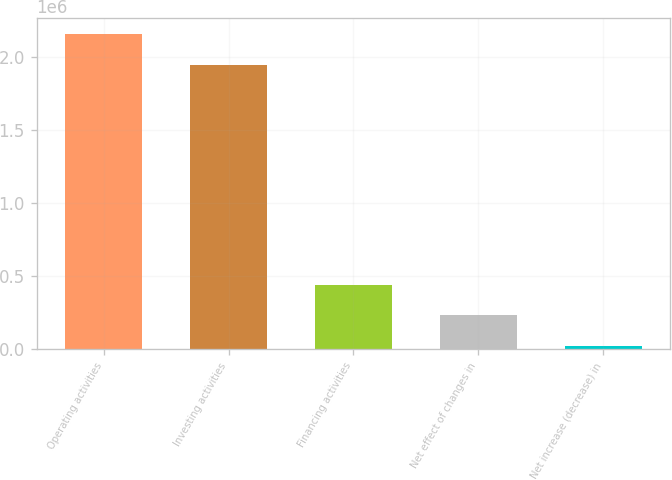Convert chart to OTSL. <chart><loc_0><loc_0><loc_500><loc_500><bar_chart><fcel>Operating activities<fcel>Investing activities<fcel>Financing activities<fcel>Net effect of changes in<fcel>Net increase (decrease) in<nl><fcel>2.16102e+06<fcel>1.94955e+06<fcel>442851<fcel>231383<fcel>19916<nl></chart> 